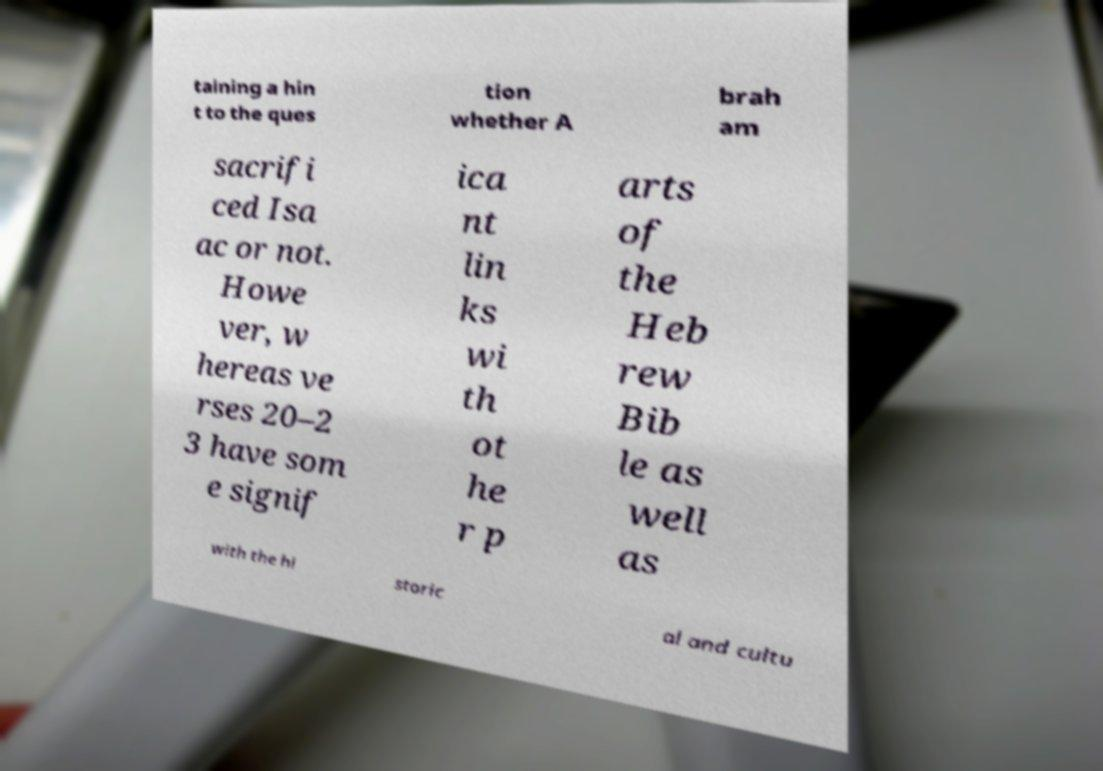What messages or text are displayed in this image? I need them in a readable, typed format. taining a hin t to the ques tion whether A brah am sacrifi ced Isa ac or not. Howe ver, w hereas ve rses 20–2 3 have som e signif ica nt lin ks wi th ot he r p arts of the Heb rew Bib le as well as with the hi storic al and cultu 